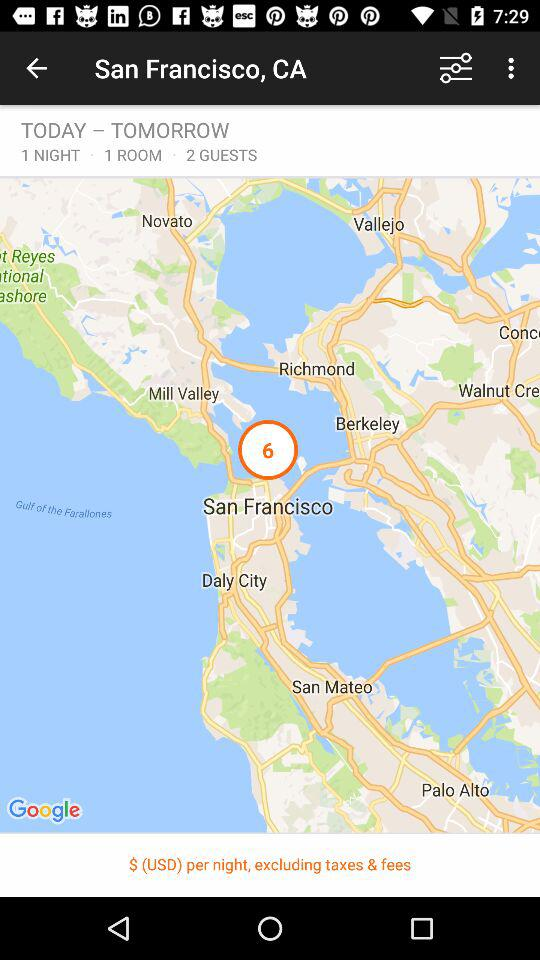What is the current location? The current location is San Francisco, CA. 